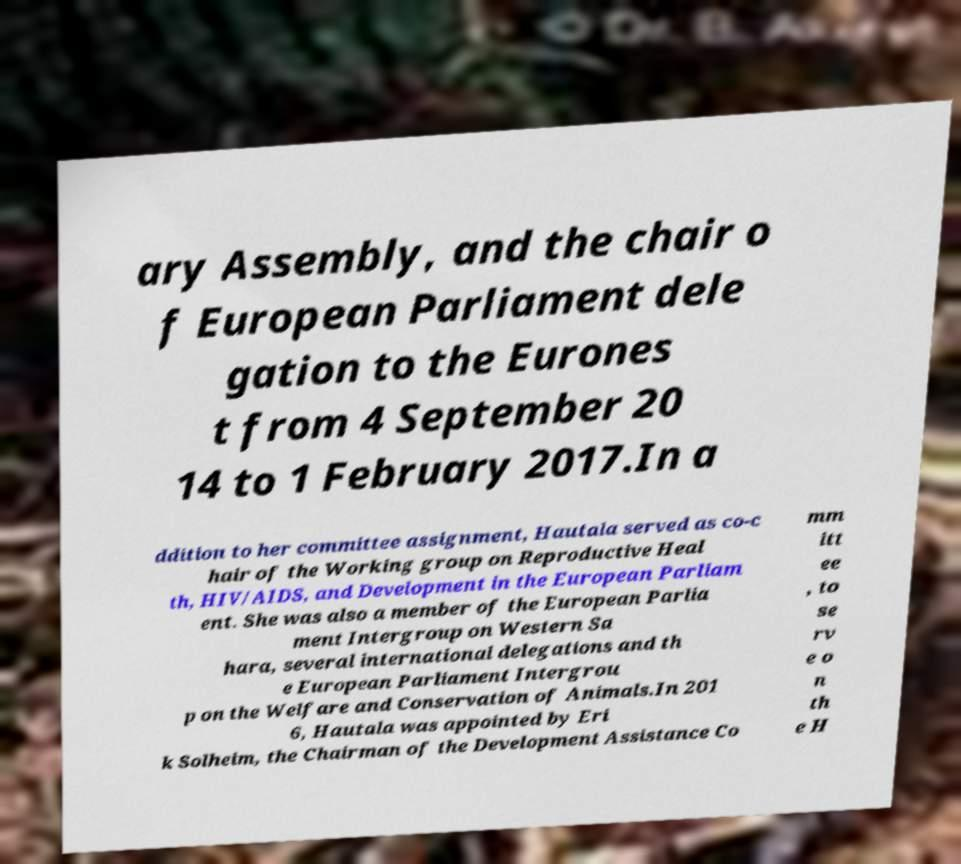What messages or text are displayed in this image? I need them in a readable, typed format. ary Assembly, and the chair o f European Parliament dele gation to the Eurones t from 4 September 20 14 to 1 February 2017.In a ddition to her committee assignment, Hautala served as co-c hair of the Working group on Reproductive Heal th, HIV/AIDS, and Development in the European Parliam ent. She was also a member of the European Parlia ment Intergroup on Western Sa hara, several international delegations and th e European Parliament Intergrou p on the Welfare and Conservation of Animals.In 201 6, Hautala was appointed by Eri k Solheim, the Chairman of the Development Assistance Co mm itt ee , to se rv e o n th e H 